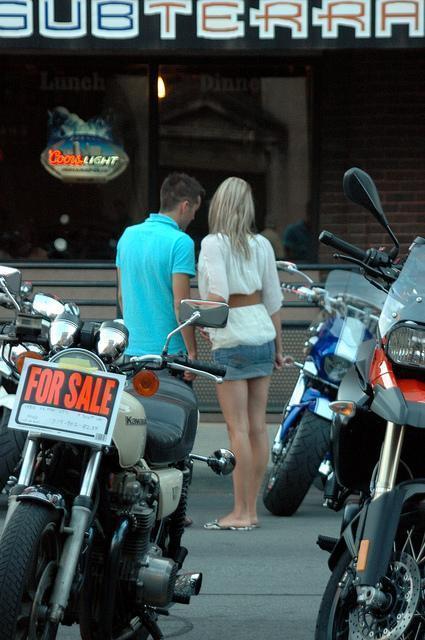What kind of shop is shown in the background?
Choose the correct response and explain in the format: 'Answer: answer
Rationale: rationale.'
Options: Car dealer, department store, bar, grocery store. Answer: bar.
Rationale: There is a sign in the window for the business advertising beer. 